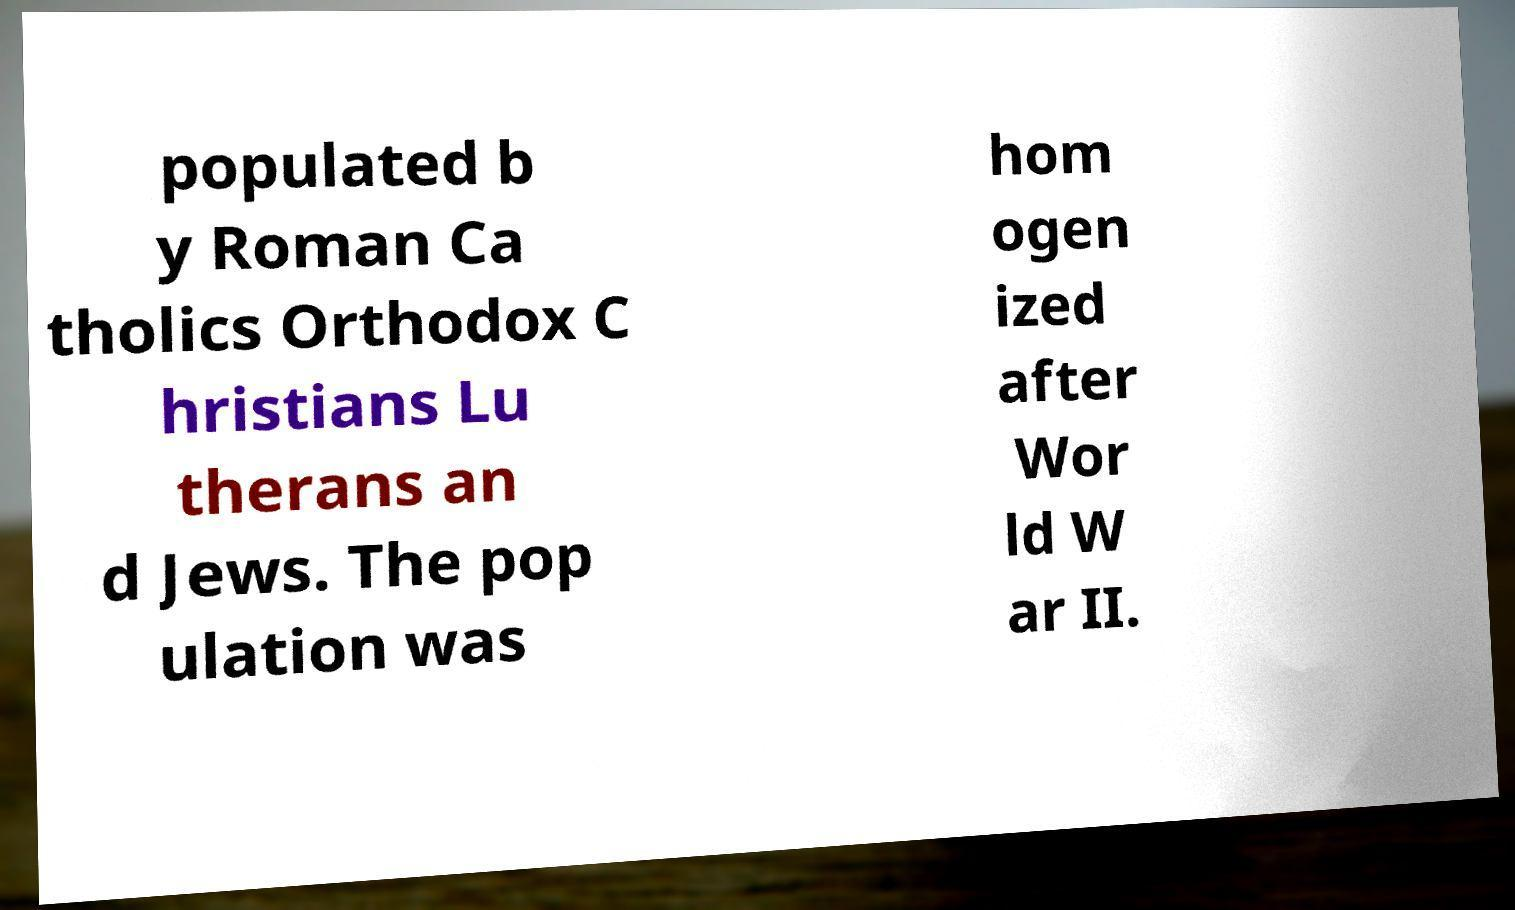Can you read and provide the text displayed in the image?This photo seems to have some interesting text. Can you extract and type it out for me? populated b y Roman Ca tholics Orthodox C hristians Lu therans an d Jews. The pop ulation was hom ogen ized after Wor ld W ar II. 